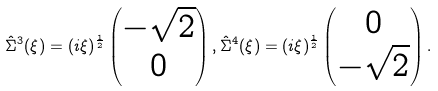<formula> <loc_0><loc_0><loc_500><loc_500>\hat { \Sigma } ^ { 3 } ( \xi ) = ( i \xi ) ^ { \frac { 1 } { 2 } } \begin{pmatrix} - \sqrt { 2 } \\ 0 \end{pmatrix} , \hat { \Sigma } ^ { 4 } ( \xi ) = ( i \xi ) ^ { \frac { 1 } { 2 } } \begin{pmatrix} 0 \\ - \sqrt { 2 } \end{pmatrix} .</formula> 